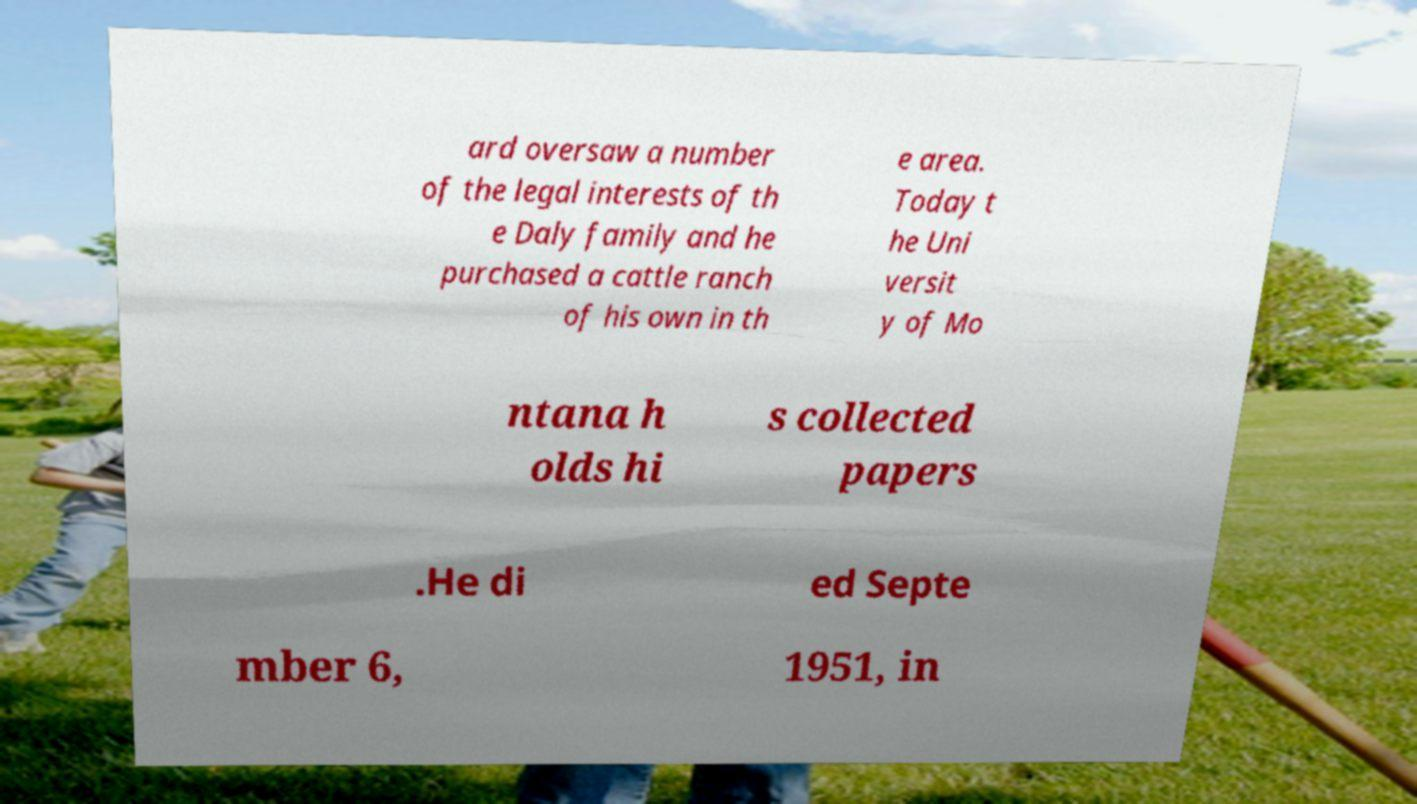Could you extract and type out the text from this image? ard oversaw a number of the legal interests of th e Daly family and he purchased a cattle ranch of his own in th e area. Today t he Uni versit y of Mo ntana h olds hi s collected papers .He di ed Septe mber 6, 1951, in 